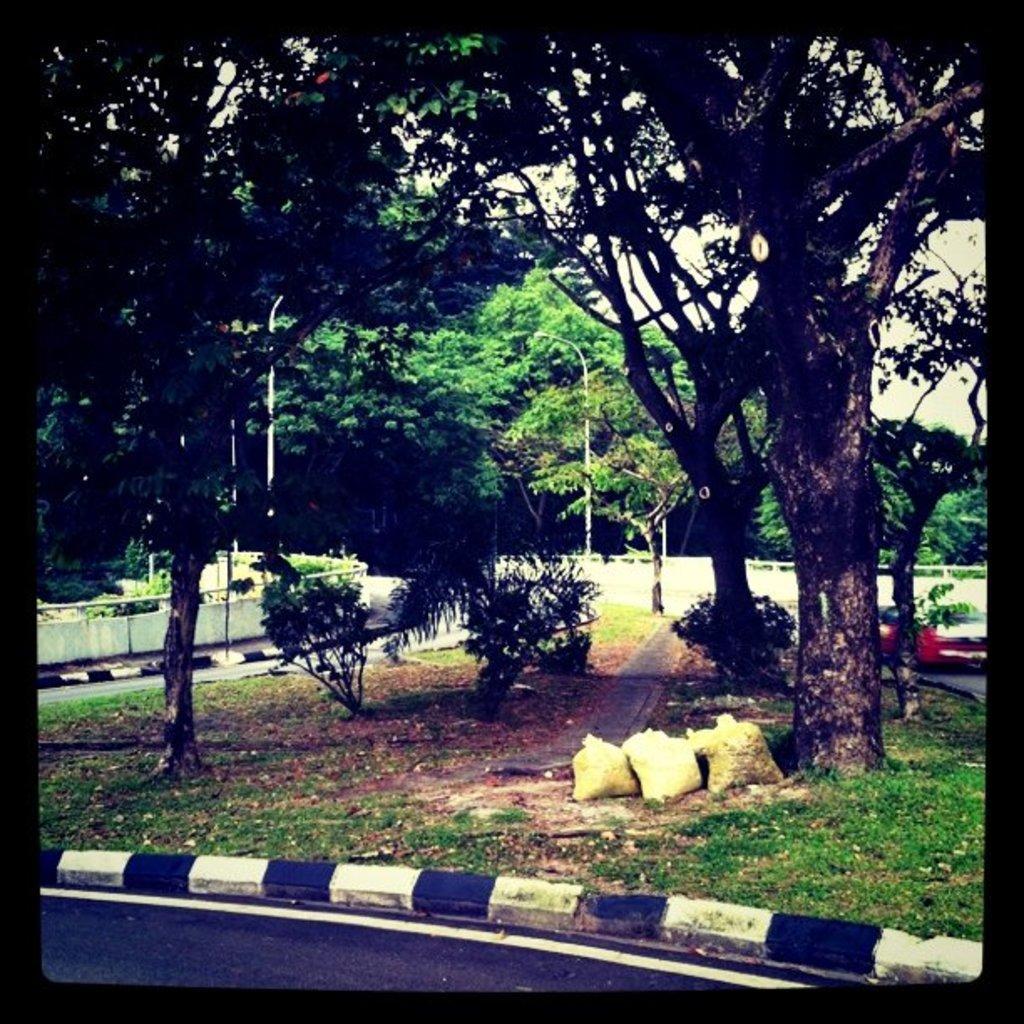In one or two sentences, can you explain what this image depicts? Beside the road there is some grass, three bags and few trees and plants in a small area, on the right side there is a car parked beside the road and in the background there are plenty of trees. 